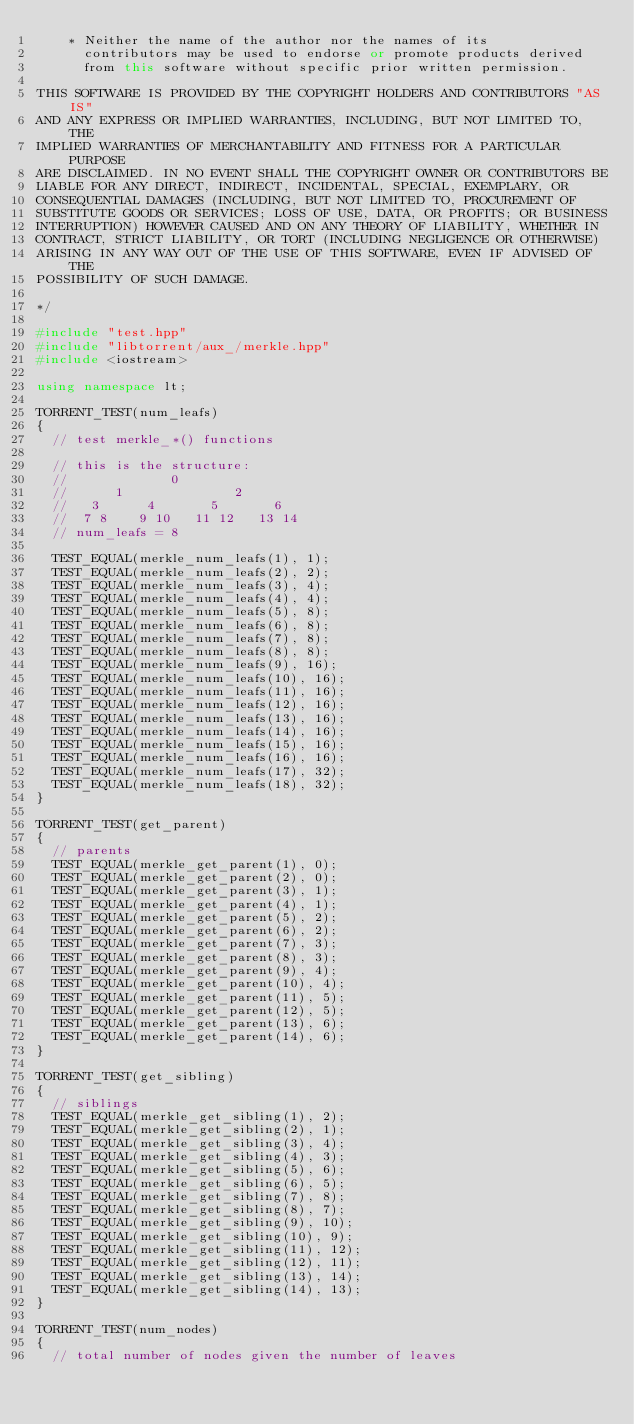<code> <loc_0><loc_0><loc_500><loc_500><_C++_>    * Neither the name of the author nor the names of its
      contributors may be used to endorse or promote products derived
      from this software without specific prior written permission.

THIS SOFTWARE IS PROVIDED BY THE COPYRIGHT HOLDERS AND CONTRIBUTORS "AS IS"
AND ANY EXPRESS OR IMPLIED WARRANTIES, INCLUDING, BUT NOT LIMITED TO, THE
IMPLIED WARRANTIES OF MERCHANTABILITY AND FITNESS FOR A PARTICULAR PURPOSE
ARE DISCLAIMED. IN NO EVENT SHALL THE COPYRIGHT OWNER OR CONTRIBUTORS BE
LIABLE FOR ANY DIRECT, INDIRECT, INCIDENTAL, SPECIAL, EXEMPLARY, OR
CONSEQUENTIAL DAMAGES (INCLUDING, BUT NOT LIMITED TO, PROCUREMENT OF
SUBSTITUTE GOODS OR SERVICES; LOSS OF USE, DATA, OR PROFITS; OR BUSINESS
INTERRUPTION) HOWEVER CAUSED AND ON ANY THEORY OF LIABILITY, WHETHER IN
CONTRACT, STRICT LIABILITY, OR TORT (INCLUDING NEGLIGENCE OR OTHERWISE)
ARISING IN ANY WAY OUT OF THE USE OF THIS SOFTWARE, EVEN IF ADVISED OF THE
POSSIBILITY OF SUCH DAMAGE.

*/

#include "test.hpp"
#include "libtorrent/aux_/merkle.hpp"
#include <iostream>

using namespace lt;

TORRENT_TEST(num_leafs)
{
	// test merkle_*() functions

	// this is the structure:
	//             0
	//      1              2
	//   3      4       5       6
	//  7 8    9 10   11 12   13 14
	// num_leafs = 8

	TEST_EQUAL(merkle_num_leafs(1), 1);
	TEST_EQUAL(merkle_num_leafs(2), 2);
	TEST_EQUAL(merkle_num_leafs(3), 4);
	TEST_EQUAL(merkle_num_leafs(4), 4);
	TEST_EQUAL(merkle_num_leafs(5), 8);
	TEST_EQUAL(merkle_num_leafs(6), 8);
	TEST_EQUAL(merkle_num_leafs(7), 8);
	TEST_EQUAL(merkle_num_leafs(8), 8);
	TEST_EQUAL(merkle_num_leafs(9), 16);
	TEST_EQUAL(merkle_num_leafs(10), 16);
	TEST_EQUAL(merkle_num_leafs(11), 16);
	TEST_EQUAL(merkle_num_leafs(12), 16);
	TEST_EQUAL(merkle_num_leafs(13), 16);
	TEST_EQUAL(merkle_num_leafs(14), 16);
	TEST_EQUAL(merkle_num_leafs(15), 16);
	TEST_EQUAL(merkle_num_leafs(16), 16);
	TEST_EQUAL(merkle_num_leafs(17), 32);
	TEST_EQUAL(merkle_num_leafs(18), 32);
}

TORRENT_TEST(get_parent)
{
	// parents
	TEST_EQUAL(merkle_get_parent(1), 0);
	TEST_EQUAL(merkle_get_parent(2), 0);
	TEST_EQUAL(merkle_get_parent(3), 1);
	TEST_EQUAL(merkle_get_parent(4), 1);
	TEST_EQUAL(merkle_get_parent(5), 2);
	TEST_EQUAL(merkle_get_parent(6), 2);
	TEST_EQUAL(merkle_get_parent(7), 3);
	TEST_EQUAL(merkle_get_parent(8), 3);
	TEST_EQUAL(merkle_get_parent(9), 4);
	TEST_EQUAL(merkle_get_parent(10), 4);
	TEST_EQUAL(merkle_get_parent(11), 5);
	TEST_EQUAL(merkle_get_parent(12), 5);
	TEST_EQUAL(merkle_get_parent(13), 6);
	TEST_EQUAL(merkle_get_parent(14), 6);
}

TORRENT_TEST(get_sibling)
{
	// siblings
	TEST_EQUAL(merkle_get_sibling(1), 2);
	TEST_EQUAL(merkle_get_sibling(2), 1);
	TEST_EQUAL(merkle_get_sibling(3), 4);
	TEST_EQUAL(merkle_get_sibling(4), 3);
	TEST_EQUAL(merkle_get_sibling(5), 6);
	TEST_EQUAL(merkle_get_sibling(6), 5);
	TEST_EQUAL(merkle_get_sibling(7), 8);
	TEST_EQUAL(merkle_get_sibling(8), 7);
	TEST_EQUAL(merkle_get_sibling(9), 10);
	TEST_EQUAL(merkle_get_sibling(10), 9);
	TEST_EQUAL(merkle_get_sibling(11), 12);
	TEST_EQUAL(merkle_get_sibling(12), 11);
	TEST_EQUAL(merkle_get_sibling(13), 14);
	TEST_EQUAL(merkle_get_sibling(14), 13);
}

TORRENT_TEST(num_nodes)
{
	// total number of nodes given the number of leaves</code> 